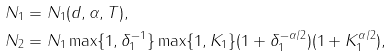Convert formula to latex. <formula><loc_0><loc_0><loc_500><loc_500>N _ { 1 } & = N _ { 1 } ( d , \alpha , T ) , \\ N _ { 2 } & = N _ { 1 } \max \{ 1 , \delta _ { 1 } ^ { - 1 } \} \max \{ 1 , K _ { 1 } \} ( 1 + \delta _ { 1 } ^ { - \alpha / 2 } ) ( 1 + K _ { 1 } ^ { \alpha / 2 } ) ,</formula> 